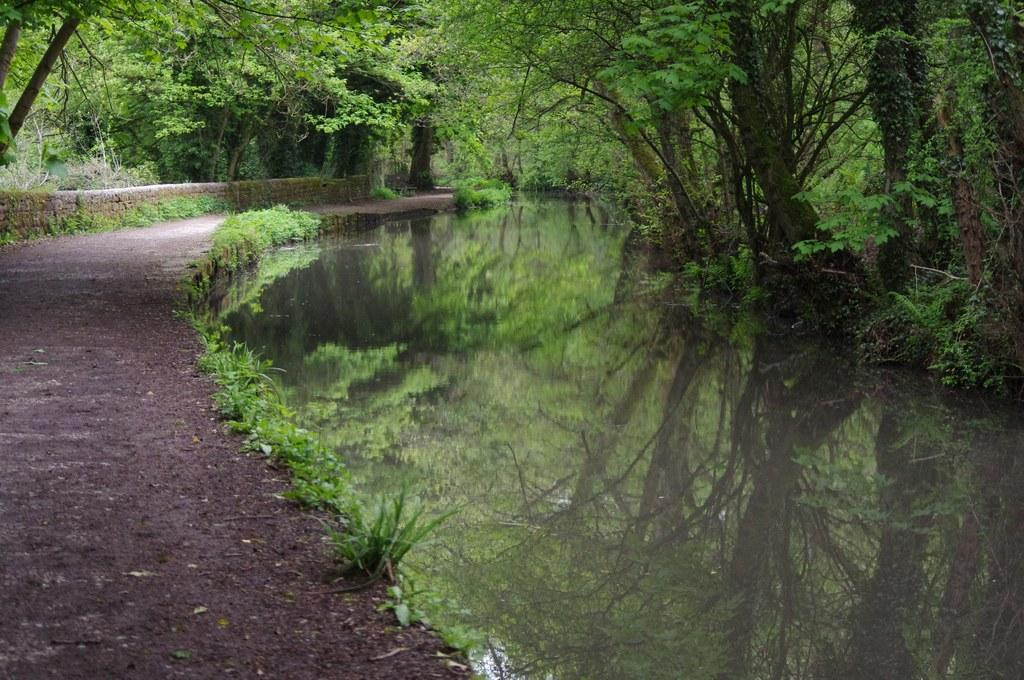Where was the picture taken? The picture was clicked outside. What can be seen on the right side of the image? There is a water body on the right side of the image. What type of vegetation is visible in the image? Trees and plants are visible in the image. What is located on the left side of the image? There is a path on the left side of the image. What is visible in the background of the image? Trees are present in the background of the image. What thought is expressed by the water body in the image? The water body does not express any thoughts; it is an inanimate object. 